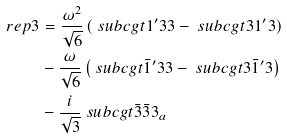<formula> <loc_0><loc_0><loc_500><loc_500>\ r e p { 3 } & = \frac { \omega ^ { 2 } } { \sqrt { 6 } } \left ( \ s u b c g t { 1 ^ { \prime } } { 3 } { 3 } - \ s u b c g t { 3 } { 1 ^ { \prime } } { 3 } \right ) \\ & - \frac { \omega } { \sqrt { 6 } } \left ( \ s u b c g t { \bar { 1 } ^ { \prime } } { 3 } { 3 } - \ s u b c g t { 3 } { \bar { 1 } ^ { \prime } } { 3 } \right ) \\ & - \frac { i } { \sqrt { 3 } } \ s u b c g t { \bar { 3 } } { \bar { 3 } } { 3 _ { a } }</formula> 